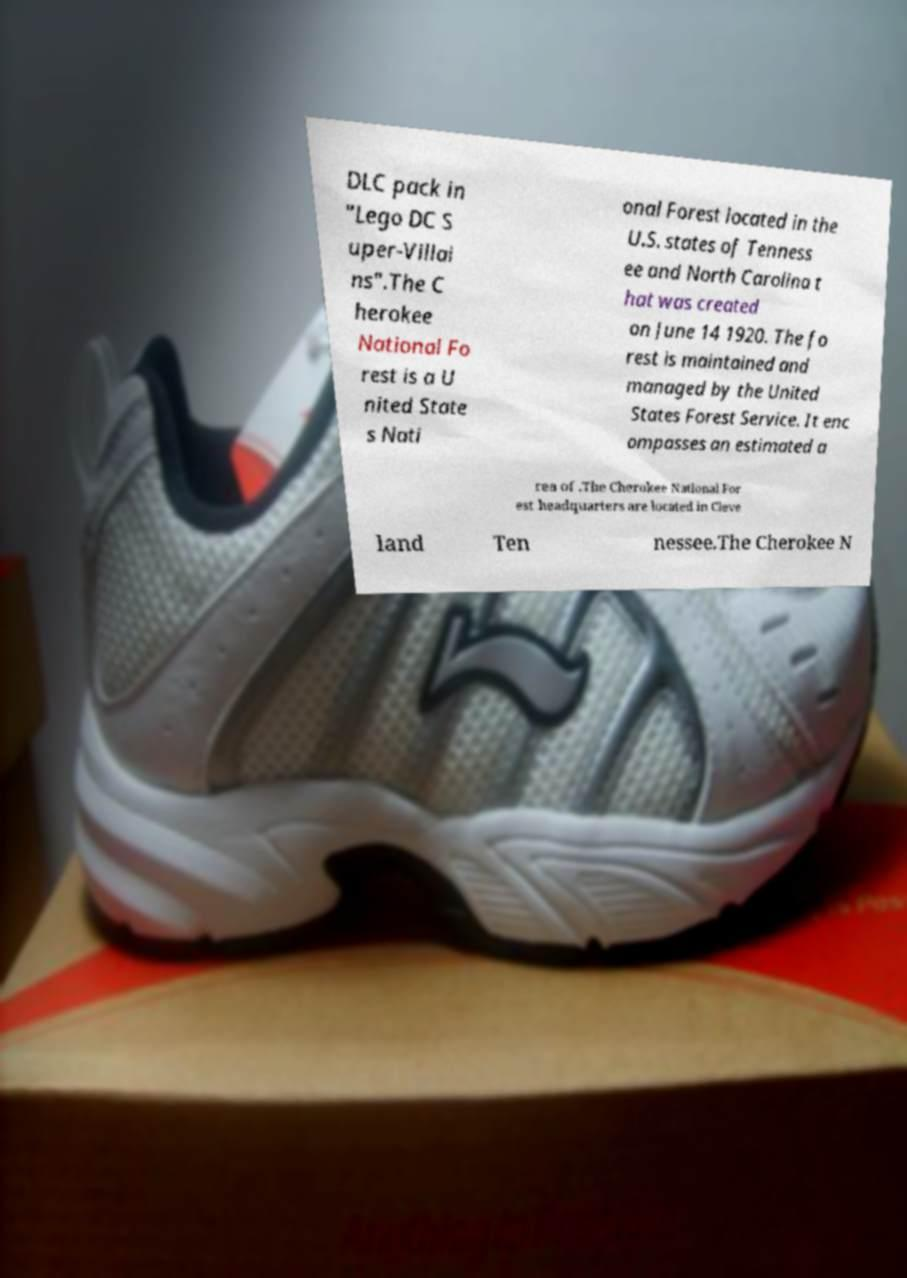Could you assist in decoding the text presented in this image and type it out clearly? DLC pack in "Lego DC S uper-Villai ns".The C herokee National Fo rest is a U nited State s Nati onal Forest located in the U.S. states of Tenness ee and North Carolina t hat was created on June 14 1920. The fo rest is maintained and managed by the United States Forest Service. It enc ompasses an estimated a rea of .The Cherokee National For est headquarters are located in Cleve land Ten nessee.The Cherokee N 